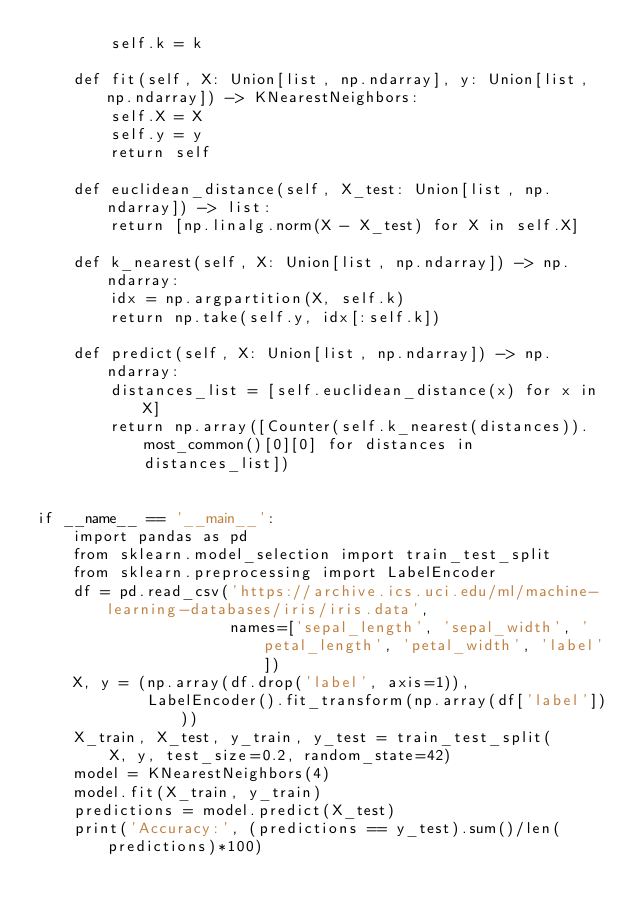Convert code to text. <code><loc_0><loc_0><loc_500><loc_500><_Python_>        self.k = k

    def fit(self, X: Union[list, np.ndarray], y: Union[list, np.ndarray]) -> KNearestNeighbors:
        self.X = X
        self.y = y
        return self

    def euclidean_distance(self, X_test: Union[list, np.ndarray]) -> list:
        return [np.linalg.norm(X - X_test) for X in self.X]

    def k_nearest(self, X: Union[list, np.ndarray]) -> np.ndarray:
        idx = np.argpartition(X, self.k)
        return np.take(self.y, idx[:self.k])

    def predict(self, X: Union[list, np.ndarray]) -> np.ndarray:
        distances_list = [self.euclidean_distance(x) for x in X]
        return np.array([Counter(self.k_nearest(distances)).most_common()[0][0] for distances in distances_list])


if __name__ == '__main__':
    import pandas as pd
    from sklearn.model_selection import train_test_split
    from sklearn.preprocessing import LabelEncoder
    df = pd.read_csv('https://archive.ics.uci.edu/ml/machine-learning-databases/iris/iris.data',
                     names=['sepal_length', 'sepal_width', 'petal_length', 'petal_width', 'label'])
    X, y = (np.array(df.drop('label', axis=1)),
            LabelEncoder().fit_transform(np.array(df['label'])))
    X_train, X_test, y_train, y_test = train_test_split(
        X, y, test_size=0.2, random_state=42)
    model = KNearestNeighbors(4)
    model.fit(X_train, y_train)
    predictions = model.predict(X_test)
    print('Accuracy:', (predictions == y_test).sum()/len(predictions)*100)
</code> 